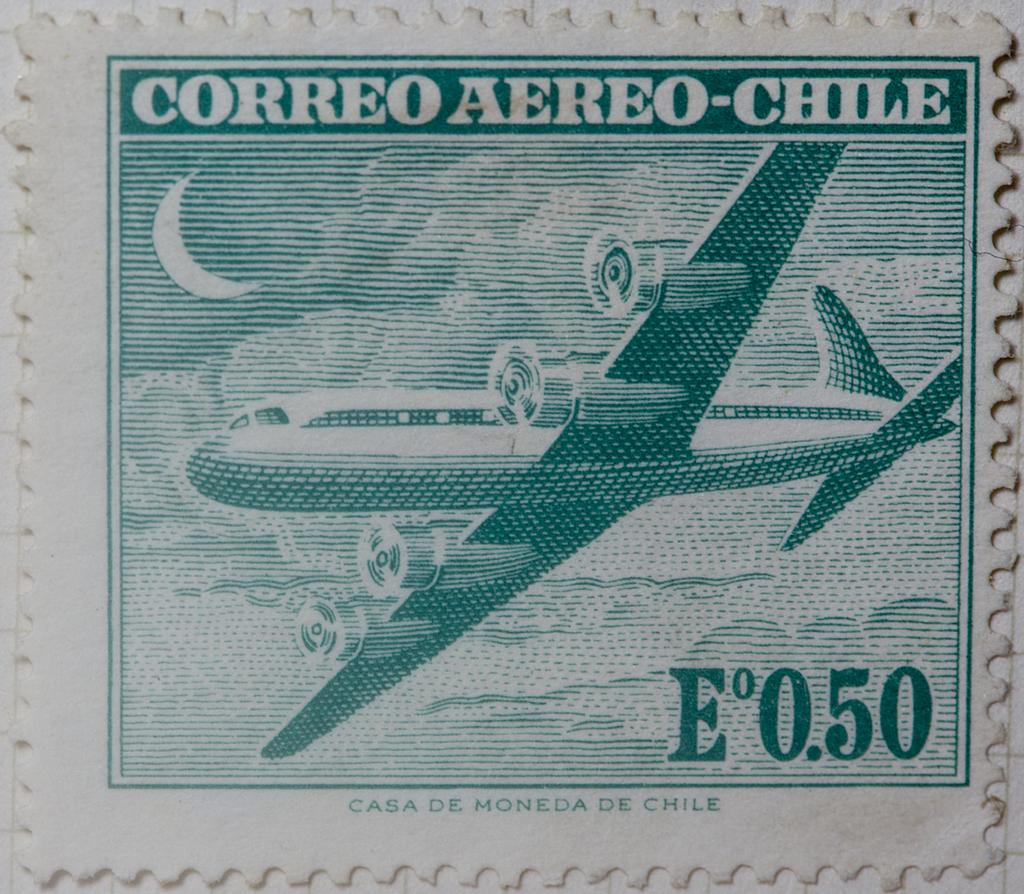What object is the main focus of the image? There is a stamp in the image. What is depicted on the stamp? The stamp has the image of an airplane. What type of doctor is featured on the stamp? There is no doctor featured on the stamp; it has the image of an airplane. What type of crib is visible in the image? There is no crib present in the image; it only features a stamp with an airplane. 